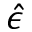Convert formula to latex. <formula><loc_0><loc_0><loc_500><loc_500>\hat { \epsilon }</formula> 